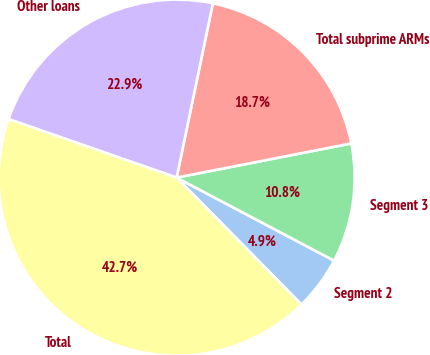Convert chart to OTSL. <chart><loc_0><loc_0><loc_500><loc_500><pie_chart><fcel>Segment 2<fcel>Segment 3<fcel>Total subprime ARMs<fcel>Other loans<fcel>Total<nl><fcel>4.91%<fcel>10.8%<fcel>18.66%<fcel>22.93%<fcel>42.7%<nl></chart> 